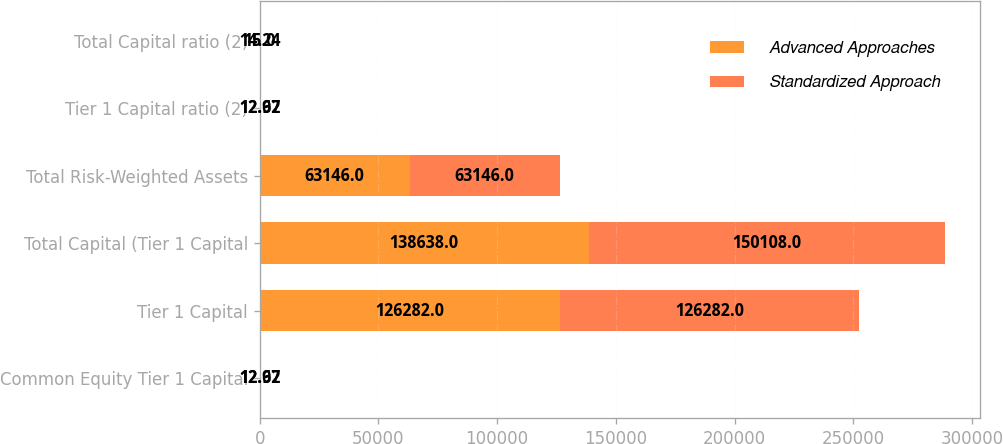Convert chart. <chart><loc_0><loc_0><loc_500><loc_500><stacked_bar_chart><ecel><fcel>Common Equity Tier 1 Capital<fcel>Tier 1 Capital<fcel>Total Capital (Tier 1 Capital<fcel>Total Risk-Weighted Assets<fcel>Tier 1 Capital ratio (2)<fcel>Total Capital ratio (2)<nl><fcel>Advanced Approaches<fcel>12.97<fcel>126282<fcel>138638<fcel>63146<fcel>12.97<fcel>14.24<nl><fcel>Standardized Approach<fcel>12.62<fcel>126282<fcel>150108<fcel>63146<fcel>12.62<fcel>15<nl></chart> 